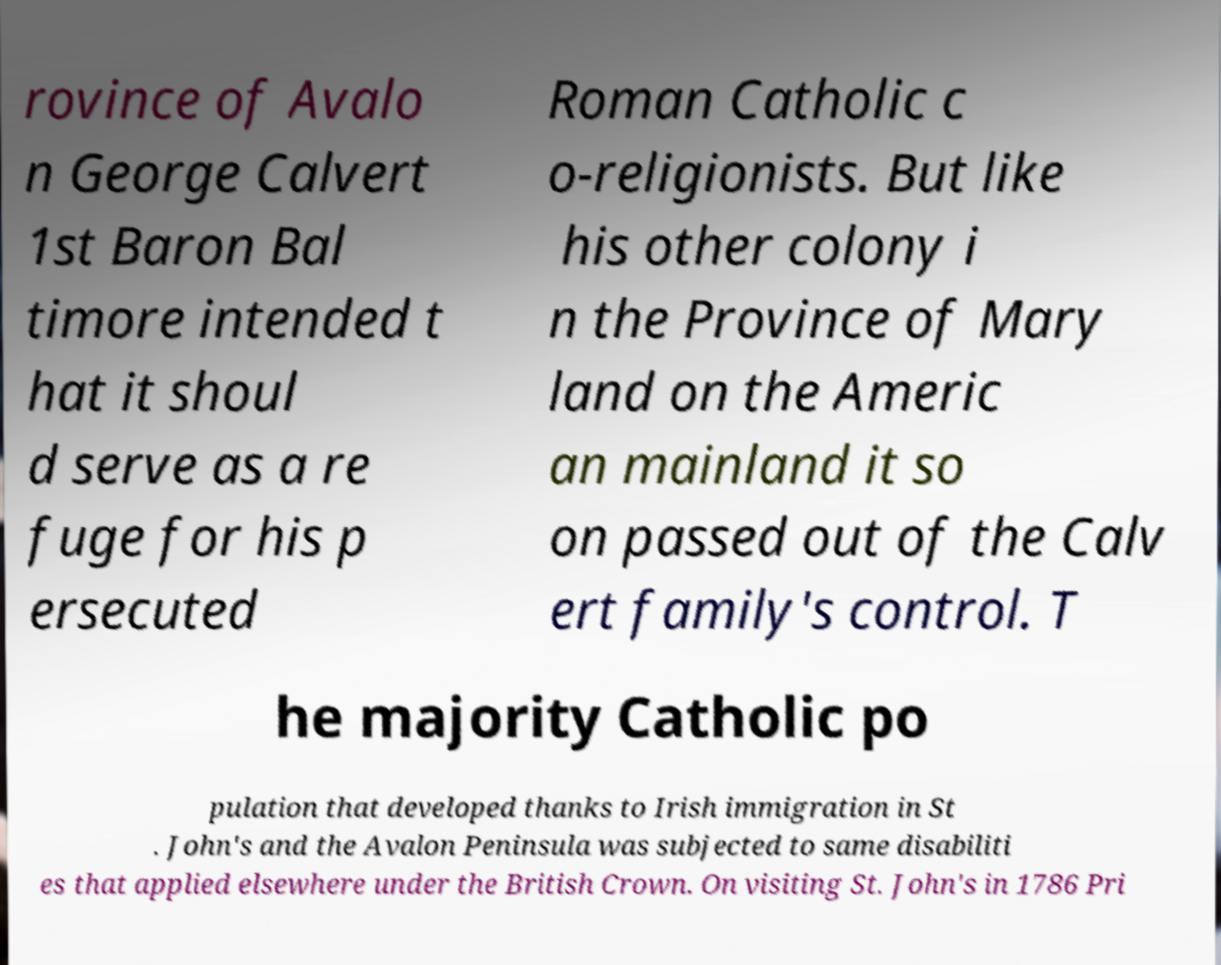Could you extract and type out the text from this image? rovince of Avalo n George Calvert 1st Baron Bal timore intended t hat it shoul d serve as a re fuge for his p ersecuted Roman Catholic c o-religionists. But like his other colony i n the Province of Mary land on the Americ an mainland it so on passed out of the Calv ert family's control. T he majority Catholic po pulation that developed thanks to Irish immigration in St . John's and the Avalon Peninsula was subjected to same disabiliti es that applied elsewhere under the British Crown. On visiting St. John's in 1786 Pri 